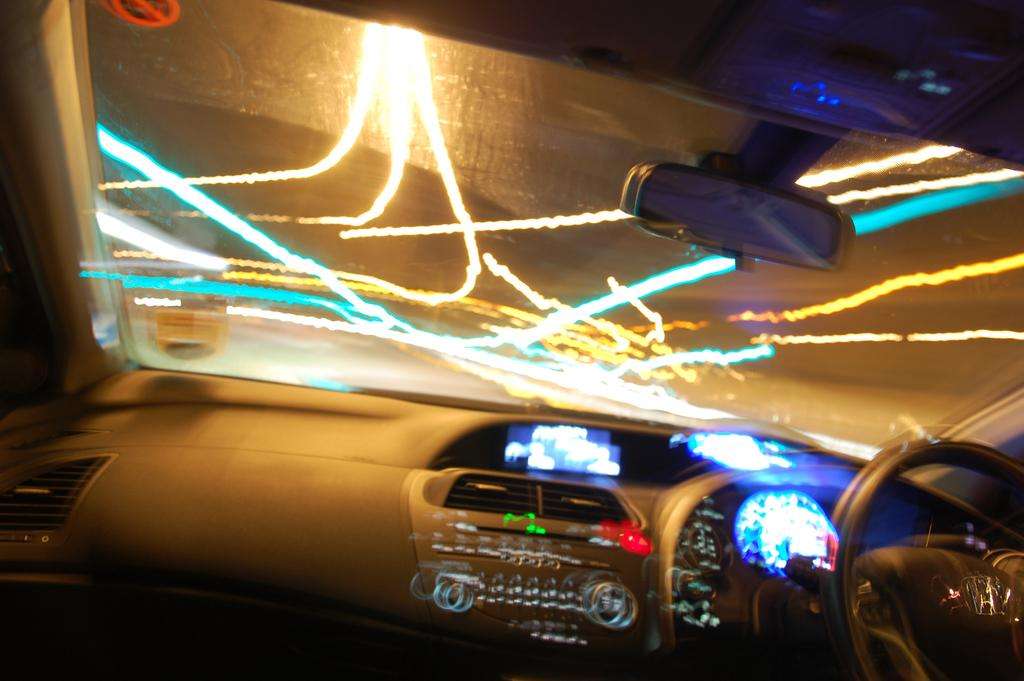What type of vehicle is shown in the image? The image shows the inner part of a vehicle, but it does not specify the type of vehicle. What is the primary control mechanism in the vehicle? There is a steering wheel in the image, which is the primary control mechanism for the vehicle. How can the driver monitor their speed in the vehicle? A speedometer is visible in the image, which allows the driver to monitor their speed. What feature is available for entertainment in the vehicle? There is a music system in the image, which provides entertainment for the driver and passengers. How can the driver see what is behind them in the vehicle? A mirror is present in the image, which allows the driver to see what is behind them. What material is used for the windows in the vehicle? There is glass in the image, which is used for the windows in the vehicle. What type of lighting is present in the vehicle? Colorful lights are visible in the image, which provide ambient lighting in the vehicle. What type of grain is stored in the throne in the image? There is no throne or grain present in the image; it shows the interior of a vehicle with various features. 